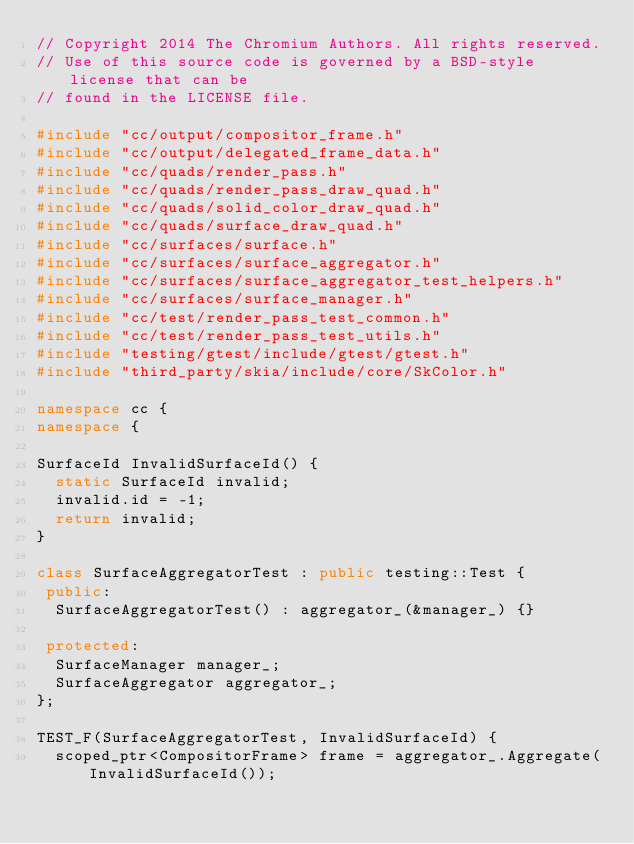Convert code to text. <code><loc_0><loc_0><loc_500><loc_500><_C++_>// Copyright 2014 The Chromium Authors. All rights reserved.
// Use of this source code is governed by a BSD-style license that can be
// found in the LICENSE file.

#include "cc/output/compositor_frame.h"
#include "cc/output/delegated_frame_data.h"
#include "cc/quads/render_pass.h"
#include "cc/quads/render_pass_draw_quad.h"
#include "cc/quads/solid_color_draw_quad.h"
#include "cc/quads/surface_draw_quad.h"
#include "cc/surfaces/surface.h"
#include "cc/surfaces/surface_aggregator.h"
#include "cc/surfaces/surface_aggregator_test_helpers.h"
#include "cc/surfaces/surface_manager.h"
#include "cc/test/render_pass_test_common.h"
#include "cc/test/render_pass_test_utils.h"
#include "testing/gtest/include/gtest/gtest.h"
#include "third_party/skia/include/core/SkColor.h"

namespace cc {
namespace {

SurfaceId InvalidSurfaceId() {
  static SurfaceId invalid;
  invalid.id = -1;
  return invalid;
}

class SurfaceAggregatorTest : public testing::Test {
 public:
  SurfaceAggregatorTest() : aggregator_(&manager_) {}

 protected:
  SurfaceManager manager_;
  SurfaceAggregator aggregator_;
};

TEST_F(SurfaceAggregatorTest, InvalidSurfaceId) {
  scoped_ptr<CompositorFrame> frame = aggregator_.Aggregate(InvalidSurfaceId());</code> 